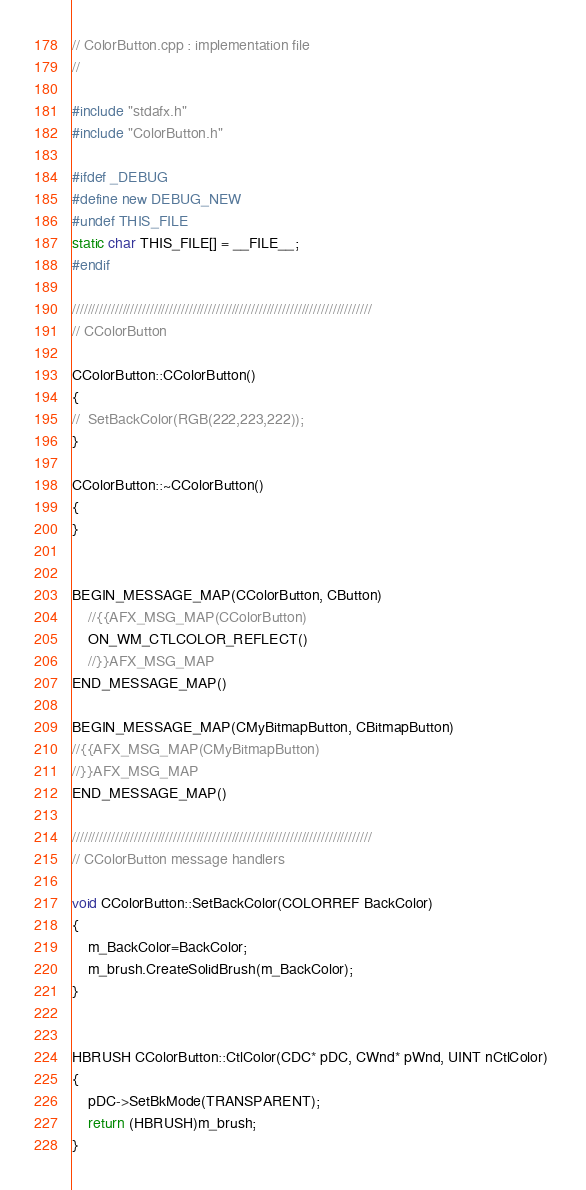<code> <loc_0><loc_0><loc_500><loc_500><_C++_>// ColorButton.cpp : implementation file
//

#include "stdafx.h"
#include "ColorButton.h"

#ifdef _DEBUG
#define new DEBUG_NEW
#undef THIS_FILE
static char THIS_FILE[] = __FILE__;
#endif

/////////////////////////////////////////////////////////////////////////////
// CColorButton

CColorButton::CColorButton()
{
//	SetBackColor(RGB(222,223,222));
}

CColorButton::~CColorButton()
{
}


BEGIN_MESSAGE_MAP(CColorButton, CButton)
	//{{AFX_MSG_MAP(CColorButton)
	ON_WM_CTLCOLOR_REFLECT()
	//}}AFX_MSG_MAP
END_MESSAGE_MAP()

BEGIN_MESSAGE_MAP(CMyBitmapButton, CBitmapButton)
//{{AFX_MSG_MAP(CMyBitmapButton)
//}}AFX_MSG_MAP
END_MESSAGE_MAP()

/////////////////////////////////////////////////////////////////////////////
// CColorButton message handlers

void CColorButton::SetBackColor(COLORREF BackColor)
{
	m_BackColor=BackColor;
	m_brush.CreateSolidBrush(m_BackColor);
}


HBRUSH CColorButton::CtlColor(CDC* pDC, CWnd* pWnd, UINT nCtlColor) 
{
	pDC->SetBkMode(TRANSPARENT);
	return (HBRUSH)m_brush;
}
</code> 